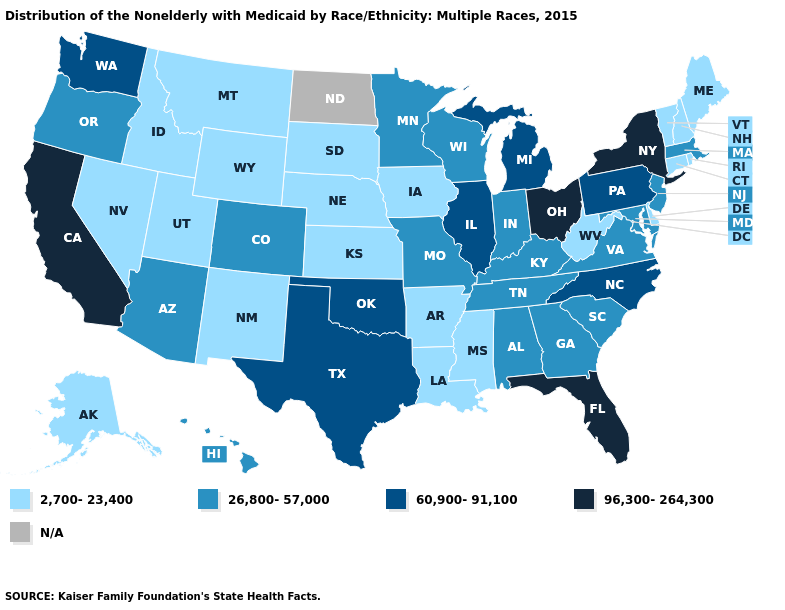Which states hav the highest value in the West?
Keep it brief. California. What is the lowest value in states that border Utah?
Quick response, please. 2,700-23,400. What is the value of Mississippi?
Short answer required. 2,700-23,400. Does Colorado have the highest value in the USA?
Concise answer only. No. Name the states that have a value in the range 26,800-57,000?
Give a very brief answer. Alabama, Arizona, Colorado, Georgia, Hawaii, Indiana, Kentucky, Maryland, Massachusetts, Minnesota, Missouri, New Jersey, Oregon, South Carolina, Tennessee, Virginia, Wisconsin. Does Oregon have the highest value in the West?
Give a very brief answer. No. Which states have the lowest value in the West?
Answer briefly. Alaska, Idaho, Montana, Nevada, New Mexico, Utah, Wyoming. What is the lowest value in the USA?
Keep it brief. 2,700-23,400. What is the value of Kentucky?
Write a very short answer. 26,800-57,000. Is the legend a continuous bar?
Answer briefly. No. What is the value of Mississippi?
Answer briefly. 2,700-23,400. How many symbols are there in the legend?
Answer briefly. 5. What is the value of Ohio?
Quick response, please. 96,300-264,300. Among the states that border New Hampshire , does Massachusetts have the lowest value?
Quick response, please. No. 